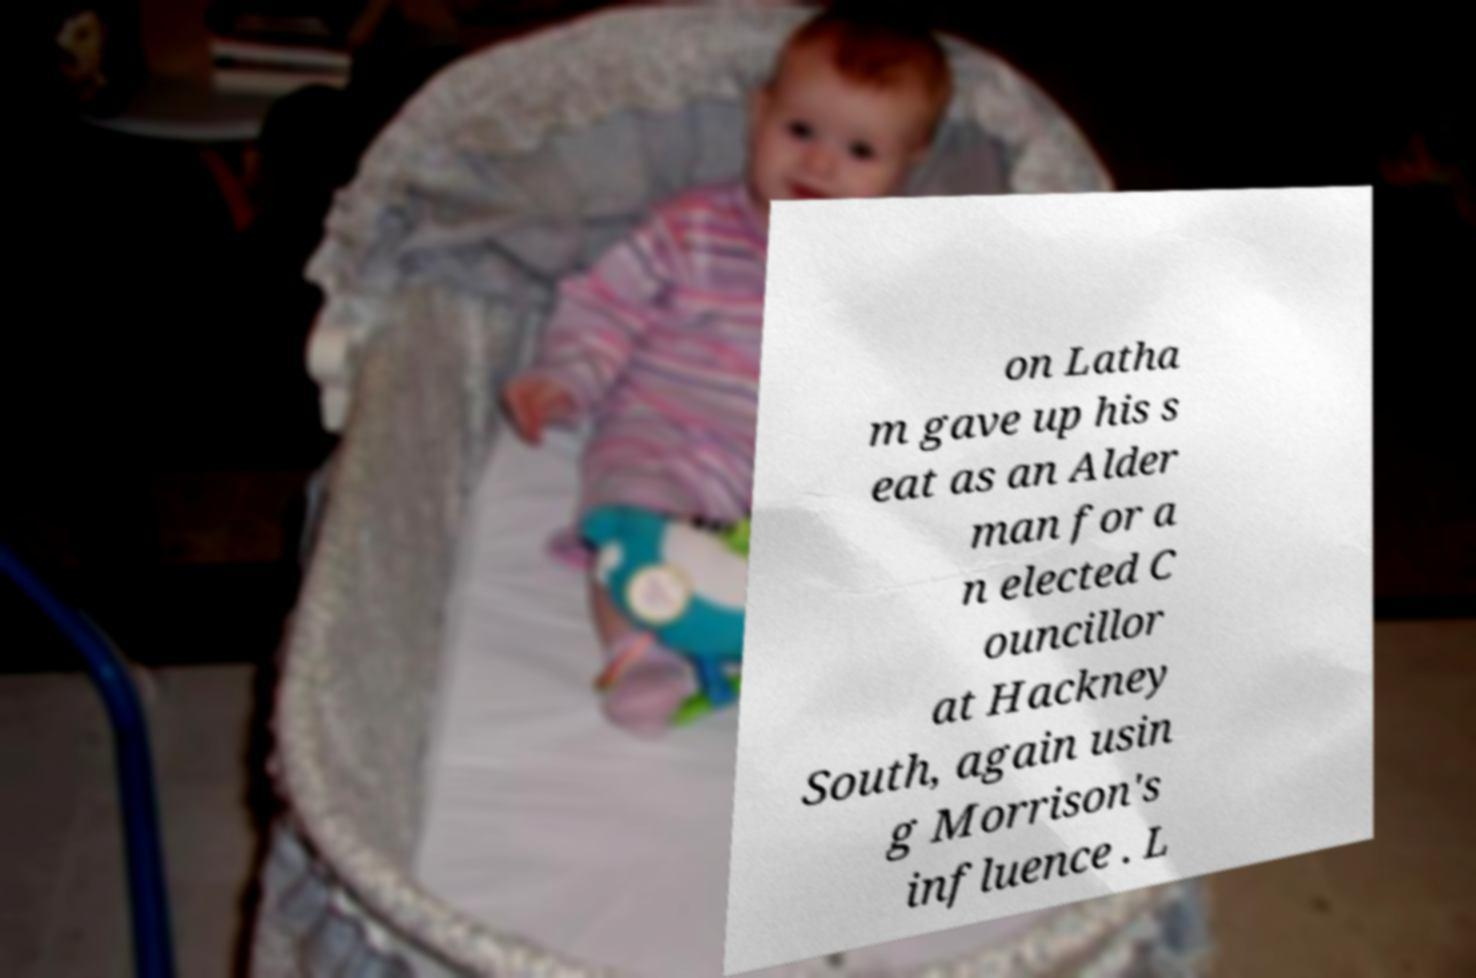I need the written content from this picture converted into text. Can you do that? on Latha m gave up his s eat as an Alder man for a n elected C ouncillor at Hackney South, again usin g Morrison's influence . L 